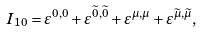<formula> <loc_0><loc_0><loc_500><loc_500>I _ { 1 0 } = \varepsilon ^ { 0 , 0 } + \varepsilon ^ { \widetilde { 0 } , \widetilde { 0 } } + \varepsilon ^ { \mu , \mu } + \varepsilon ^ { \widetilde { \mu } , \widetilde { \mu } } ,</formula> 